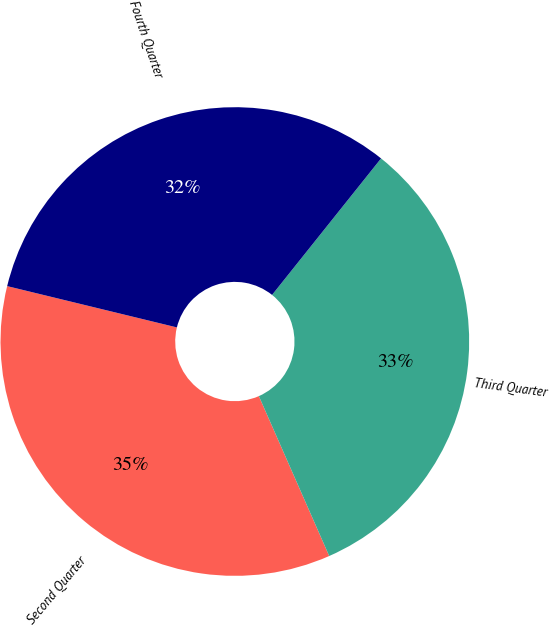Convert chart. <chart><loc_0><loc_0><loc_500><loc_500><pie_chart><fcel>Second Quarter<fcel>Third Quarter<fcel>Fourth Quarter<nl><fcel>35.4%<fcel>32.68%<fcel>31.93%<nl></chart> 